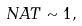<formula> <loc_0><loc_0><loc_500><loc_500>N A T \sim 1 ,</formula> 